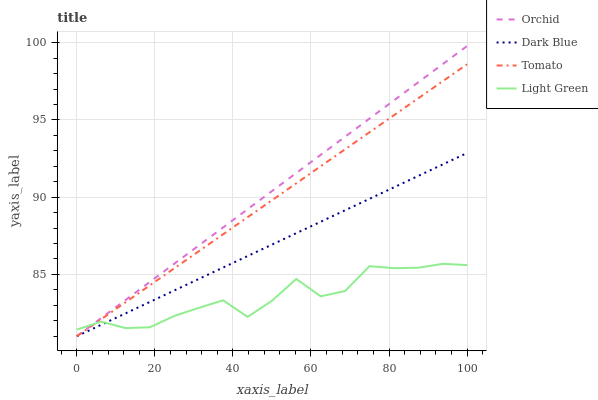Does Dark Blue have the minimum area under the curve?
Answer yes or no. No. Does Dark Blue have the maximum area under the curve?
Answer yes or no. No. Is Dark Blue the smoothest?
Answer yes or no. No. Is Dark Blue the roughest?
Answer yes or no. No. Does Light Green have the lowest value?
Answer yes or no. No. Does Dark Blue have the highest value?
Answer yes or no. No. 